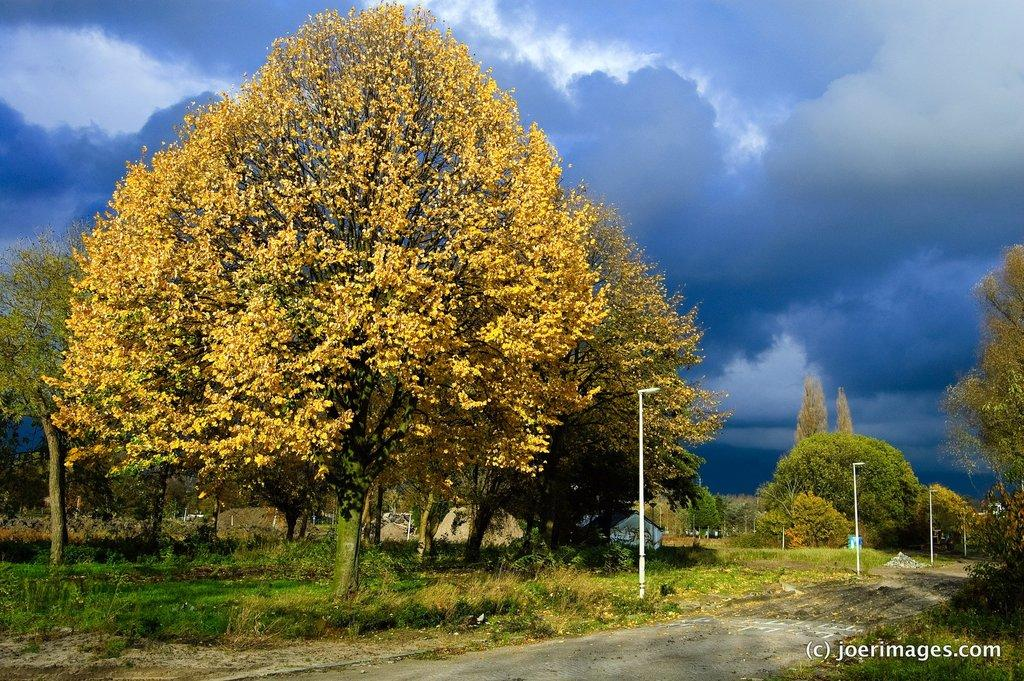What type of landscape is shown in the image? The image depicts a grassy land. What natural features can be seen in the image? There are many trees in the image. Are there any artificial structures visible in the image? Yes, there are a few street lights in the image. How would you describe the weather in the image? The sky in the image is cloudy. What type of war is being fought in the image? There is no war depicted in the image; it shows a grassy land with trees and street lights. Can you tell me how many owls are sitting on the trees in the image? There are no owls present in the image; it features a grassy land with trees and street lights. 